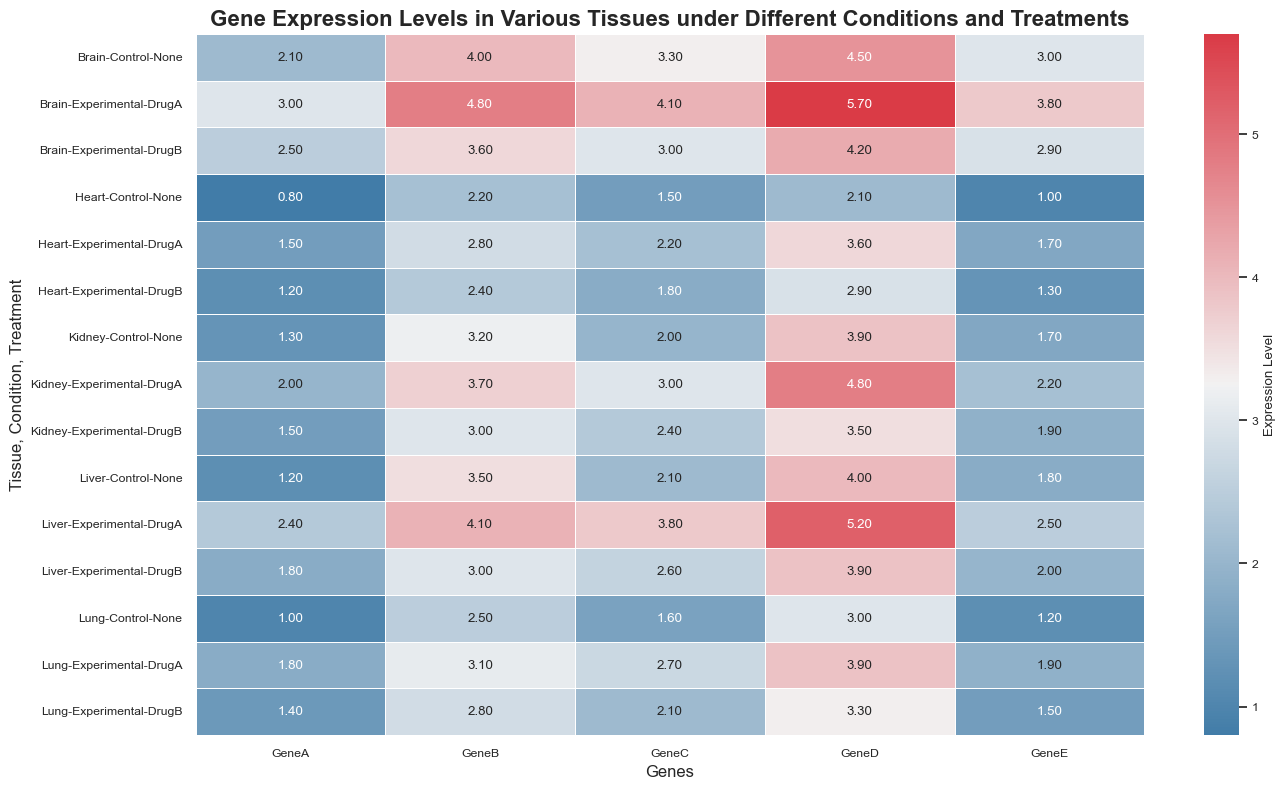Which tissue shows the highest gene expression levels for GeneD under the DrugA treatment? Look at the row corresponding to DrugA treatment for each tissue and observe the values for GeneD. The highest value is 5.7 for the Brain tissue.
Answer: Brain How does the expression of GeneB compare between Liver and Kidney under the Control condition? Compare the GeneB expression levels for the Control condition in Liver and Kidney. Liver shows 3.5 while Kidney shows 3.2, so Liver has a slightly higher expression of GeneB.
Answer: Liver What is the average expression level of GeneC across all tissues under the DrugB treatment? Sum the GeneC expression levels under DrugB treatment for all tissues: (2.6 + 1.8 + 3.0 + 2.4 + 2.1). Then divide by the number of tissues (5). The average is (2.6 + 1.8 + 3.0 + 2.4 + 2.1) / 5 = 11.9 / 5 = 2.38.
Answer: 2.38 In which condition and tissue combination does GeneA have its lowest expression level? Scan the values for GeneA across all tissues and conditions. The lowest expression level is 0.8 in the Heart tissue under the Control condition.
Answer: Heart, Control Compare the effects of DrugA and DrugB on the expression of GeneE in the Heart tissue. For the Heart tissue, under DrugA, GeneE has an expression level of 1.7, while under DrugB, it has a level of 1.3. DrugA results in a higher expression of GeneE than DrugB in the Heart tissue.
Answer: DrugA What's the change in GeneD expression in the Liver tissue when switching from Control to DrugA treatment? For the Liver tissue, GeneD expression changes from 4.0 under the Control condition to 5.2 under the DrugA treatment. The change is 5.2 - 4.0 = 1.2.
Answer: 1.2 Which gene demonstrates the most variable expression level across all tissues and conditions? By examining the heatmap, observe the range of expression levels for each gene across all tissues and conditions. GeneD demonstrates high variability, ranging from 2.1 to 5.7.
Answer: GeneD 